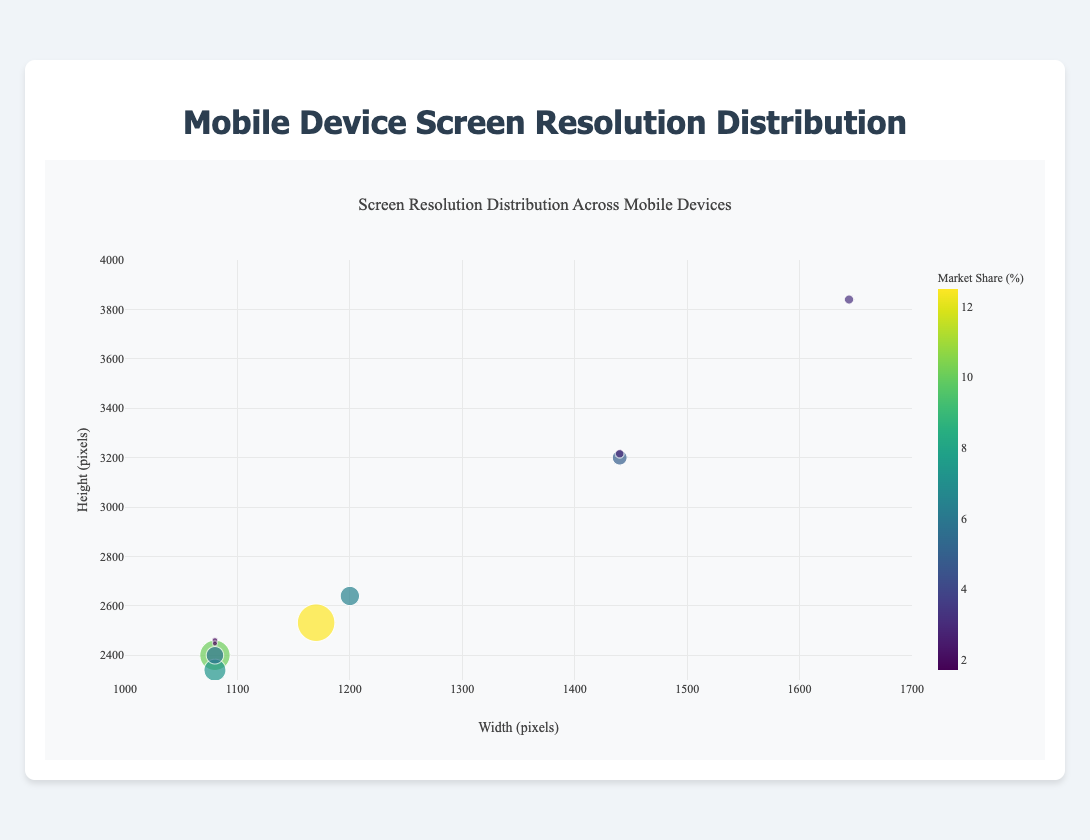Which device has the highest screen resolution? The device with the highest screen resolution can be identified by looking for the highest values on the x and y axes combined. The Sony Xperia 1 II has a resolution of 1644x3840 pixels, which is the highest on the chart.
Answer: Sony Xperia 1 II What is the market share of the iPhone 12 and how is it represented in the chart? To find the market share of the iPhone 12, look for the corresponding bubble with the label "iPhone 12." The size of the bubble represents the market share, and hovering over it reveals that the iPhone 12 has a market share of 12.5%.
Answer: 12.5% Which devices have the same screen width of 1080 pixels? To determine which devices have a screen width of 1080 pixels, locate the x-axis value of 1080 and check which bubbles are aligned vertically with this value. The devices with a screen width of 1080 pixels are the Samsung Galaxy S21, Google Pixel 5, OnePlus 8T, LG V60 ThinQ, and Asus ROG Phone 5.
Answer: Samsung Galaxy S21, Google Pixel 5, OnePlus 8T, LG V60 ThinQ, Asus ROG Phone 5 What is the range of screen height values on the plot? The range of screen height values can be found by identifying the minimum and maximum values on the y-axis. The minimum screen height is 2340 pixels (Google Pixel 5), and the maximum screen height is 3840 pixels (Sony Xperia 1 II).
Answer: 2340-3840 pixels How does the market share of the Huawei P40 Pro compare with that of the Oppo Find X3 Pro? To compare the market shares of the Huawei P40 Pro and Oppo Find X3 Pro, locate and compare their bubble sizes and market share values upon hovering over them. The Huawei P40 Pro has a market share of 6.4%, while the Oppo Find X3 Pro has a market share of 2.9%. Therefore, the Huawei P40 Pro has a higher market share.
Answer: Huawei P40 Pro has a higher market share Which device has the smallest market share and what is its screen resolution? To find the device with the smallest market share, identify the smallest bubble and hover over it to see the details. The Asus ROG Phone 5 has the smallest market share of 1.7%, and its screen resolution is 1080x2448 pixels.
Answer: Asus ROG Phone 5, 1080x2448 pixels What is the combined market share of devices with a screen height greater than 3000 pixels? To find the combined market share of devices with a screen height greater than 3000 pixels, identify those devices and sum their market shares. The devices are Xiaomi Mi 11 (4.9%), Sony Xperia 1 II (3.1%), and Oppo Find X3 Pro (2.9%). Summing these values gives 4.9% + 3.1% + 2.9% = 10.9%.
Answer: 10.9% What is the most common screen width among the devices? The most common screen width can be determined by identifying the x-axis value that aligns with the most bubbles. The x-axis value of 1080 pixels aligns with the Samsung Galaxy S21, Google Pixel 5, OnePlus 8T, LG V60 ThinQ, and Asus ROG Phone 5, making it the most common screen width.
Answer: 1080 pixels Which device falls closest to the center of the range of screen heights (i.e., around 3170 pixels)? To find the device closest to the center of the screen height range, locate the bubble nearest to the y-axis value of 3170 pixels. The Oppo Find X3 Pro has a screen height of 3216 pixels, making it closest to this center value.
Answer: Oppo Find X3 Pro How does the resolution of the iPhone 12 compare to that of the Xiaomi Mi 11 in terms of pixel count? To compare the resolution of the iPhone 12 and Xiaomi Mi 11, calculate the total pixel count for each device by multiplying their width and height. iPhone 12: 1170 * 2532 = 2,961,240 pixels. Xiaomi Mi 11: 1440 * 3200 = 4,608,000 pixels. The Xiaomi Mi 11 has a higher total pixel count.
Answer: Xiaomi Mi 11 has a higher total pixel count 